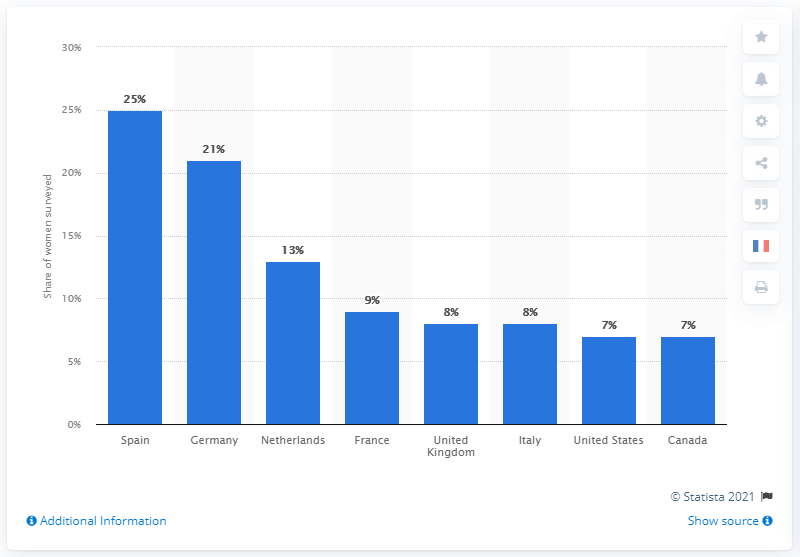Mention a couple of crucial points in this snapshot. In France, it was reported that women were less than 10 percent to have been completely naked on the beach or in a naturist camp. 